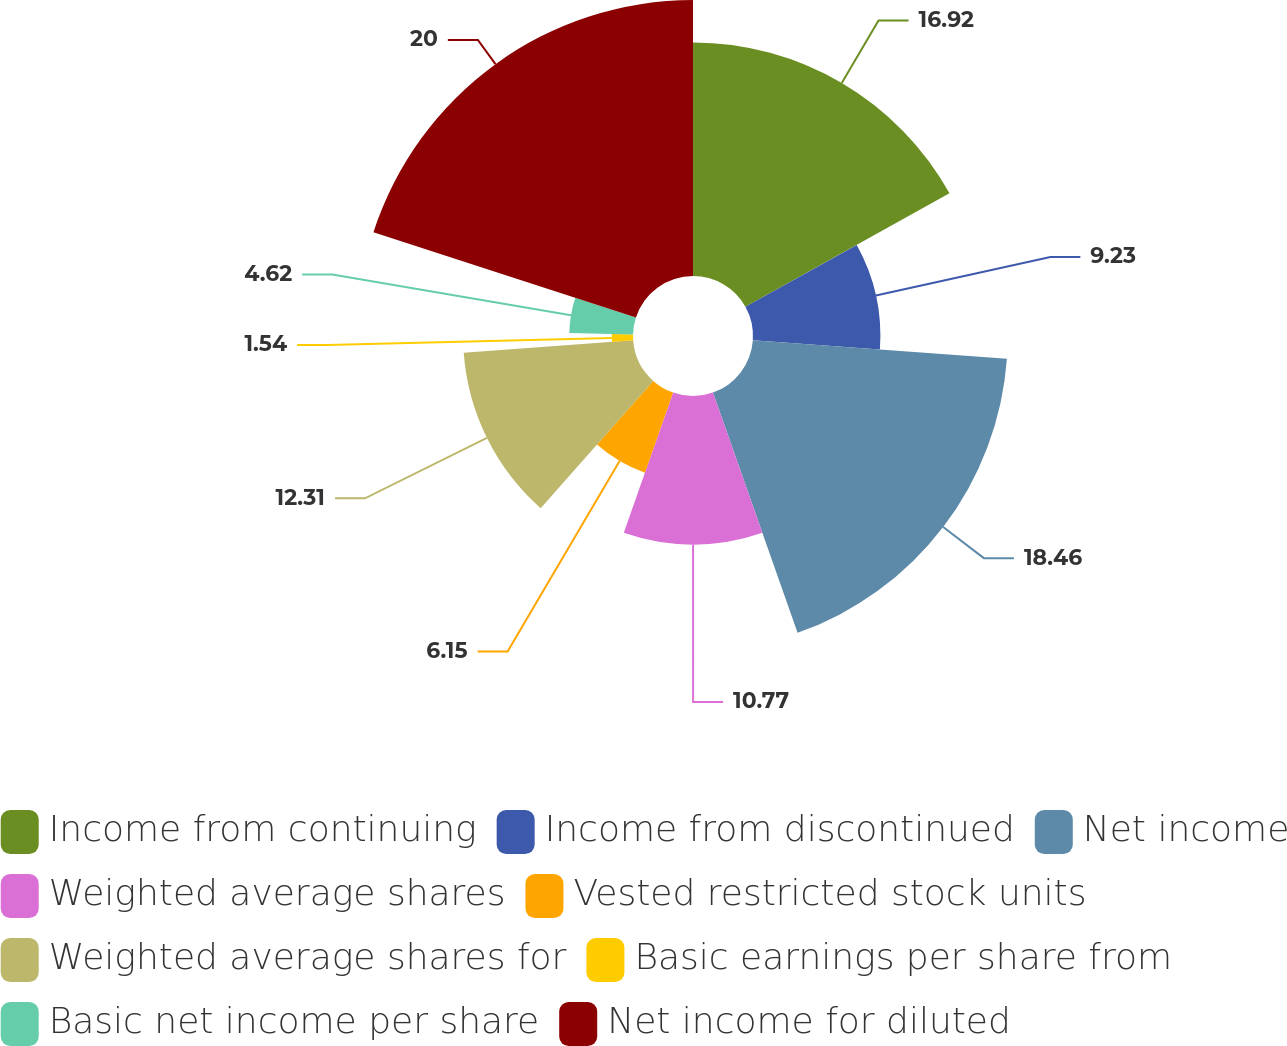<chart> <loc_0><loc_0><loc_500><loc_500><pie_chart><fcel>Income from continuing<fcel>Income from discontinued<fcel>Net income<fcel>Weighted average shares<fcel>Vested restricted stock units<fcel>Weighted average shares for<fcel>Basic earnings per share from<fcel>Basic net income per share<fcel>Net income for diluted<nl><fcel>16.92%<fcel>9.23%<fcel>18.46%<fcel>10.77%<fcel>6.15%<fcel>12.31%<fcel>1.54%<fcel>4.62%<fcel>20.0%<nl></chart> 